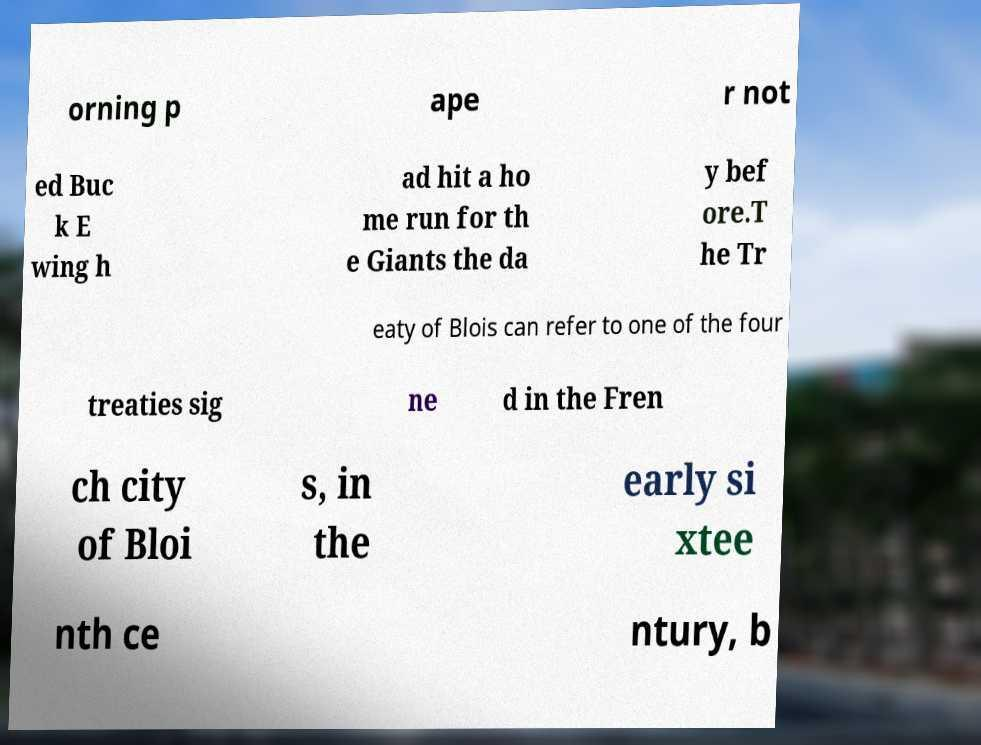Could you assist in decoding the text presented in this image and type it out clearly? orning p ape r not ed Buc k E wing h ad hit a ho me run for th e Giants the da y bef ore.T he Tr eaty of Blois can refer to one of the four treaties sig ne d in the Fren ch city of Bloi s, in the early si xtee nth ce ntury, b 